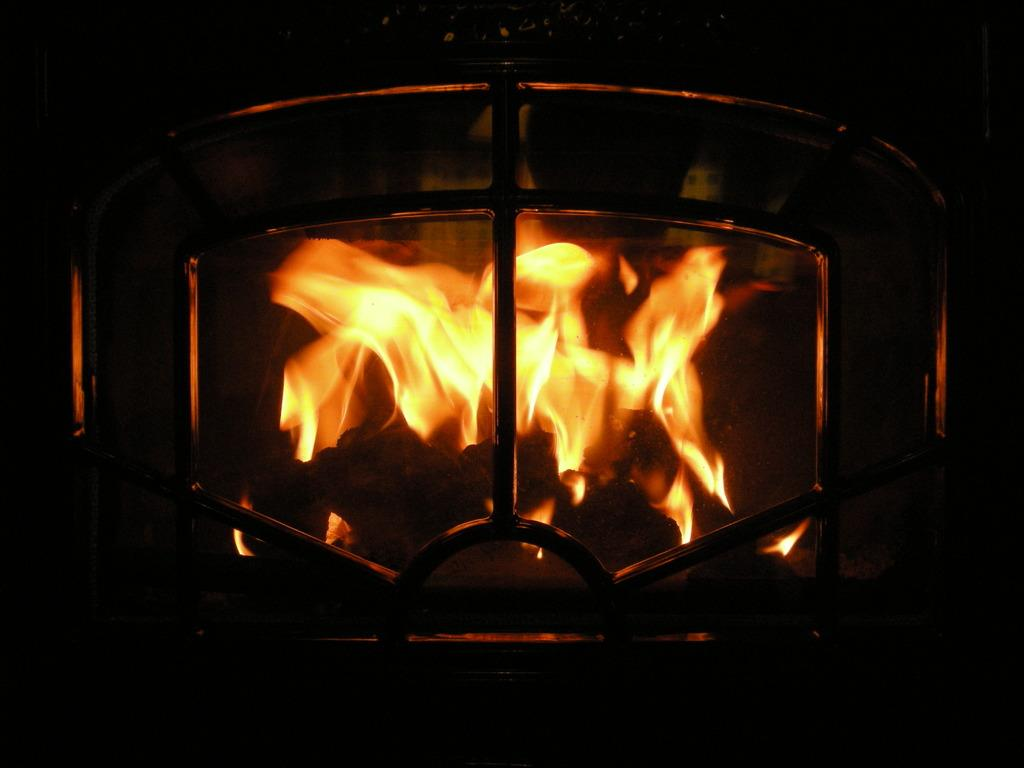What is the main subject of the image? The main subject of the image is a fire. Where is the fire located? The fire is in a firewood chimney. What type of harmony can be heard in the image? There is no audible harmony present in the image, as it features a fire in a firewood chimney. What is the monetary value of the fire in the image? The image does not provide any information about the monetary value of the fire. 